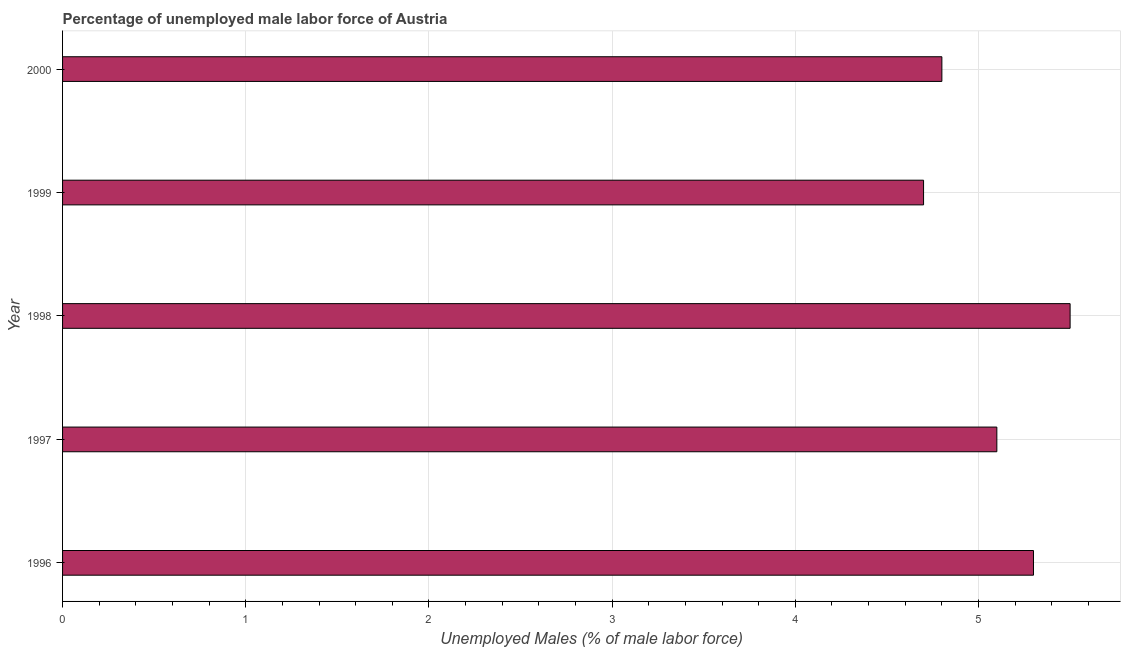Does the graph contain grids?
Your answer should be compact. Yes. What is the title of the graph?
Provide a short and direct response. Percentage of unemployed male labor force of Austria. What is the label or title of the X-axis?
Offer a terse response. Unemployed Males (% of male labor force). What is the total unemployed male labour force in 1997?
Your answer should be very brief. 5.1. Across all years, what is the maximum total unemployed male labour force?
Your answer should be compact. 5.5. Across all years, what is the minimum total unemployed male labour force?
Your answer should be very brief. 4.7. In which year was the total unemployed male labour force maximum?
Offer a very short reply. 1998. In which year was the total unemployed male labour force minimum?
Ensure brevity in your answer.  1999. What is the sum of the total unemployed male labour force?
Give a very brief answer. 25.4. What is the difference between the total unemployed male labour force in 1998 and 1999?
Offer a very short reply. 0.8. What is the average total unemployed male labour force per year?
Your answer should be very brief. 5.08. What is the median total unemployed male labour force?
Provide a succinct answer. 5.1. In how many years, is the total unemployed male labour force greater than 1 %?
Give a very brief answer. 5. What is the ratio of the total unemployed male labour force in 1996 to that in 1999?
Offer a terse response. 1.13. Is the total unemployed male labour force in 1997 less than that in 1998?
Provide a succinct answer. Yes. What is the difference between the highest and the second highest total unemployed male labour force?
Offer a very short reply. 0.2. Is the sum of the total unemployed male labour force in 1999 and 2000 greater than the maximum total unemployed male labour force across all years?
Make the answer very short. Yes. What is the difference between the highest and the lowest total unemployed male labour force?
Your answer should be very brief. 0.8. Are all the bars in the graph horizontal?
Provide a short and direct response. Yes. What is the Unemployed Males (% of male labor force) in 1996?
Offer a terse response. 5.3. What is the Unemployed Males (% of male labor force) in 1997?
Offer a terse response. 5.1. What is the Unemployed Males (% of male labor force) of 1998?
Make the answer very short. 5.5. What is the Unemployed Males (% of male labor force) in 1999?
Offer a terse response. 4.7. What is the Unemployed Males (% of male labor force) in 2000?
Offer a very short reply. 4.8. What is the difference between the Unemployed Males (% of male labor force) in 1996 and 1998?
Offer a very short reply. -0.2. What is the difference between the Unemployed Males (% of male labor force) in 1997 and 1998?
Provide a short and direct response. -0.4. What is the difference between the Unemployed Males (% of male labor force) in 1997 and 1999?
Give a very brief answer. 0.4. What is the difference between the Unemployed Males (% of male labor force) in 1998 and 1999?
Provide a succinct answer. 0.8. What is the difference between the Unemployed Males (% of male labor force) in 1998 and 2000?
Offer a terse response. 0.7. What is the difference between the Unemployed Males (% of male labor force) in 1999 and 2000?
Keep it short and to the point. -0.1. What is the ratio of the Unemployed Males (% of male labor force) in 1996 to that in 1997?
Keep it short and to the point. 1.04. What is the ratio of the Unemployed Males (% of male labor force) in 1996 to that in 1999?
Your answer should be very brief. 1.13. What is the ratio of the Unemployed Males (% of male labor force) in 1996 to that in 2000?
Provide a short and direct response. 1.1. What is the ratio of the Unemployed Males (% of male labor force) in 1997 to that in 1998?
Give a very brief answer. 0.93. What is the ratio of the Unemployed Males (% of male labor force) in 1997 to that in 1999?
Your answer should be very brief. 1.08. What is the ratio of the Unemployed Males (% of male labor force) in 1997 to that in 2000?
Make the answer very short. 1.06. What is the ratio of the Unemployed Males (% of male labor force) in 1998 to that in 1999?
Offer a very short reply. 1.17. What is the ratio of the Unemployed Males (% of male labor force) in 1998 to that in 2000?
Provide a short and direct response. 1.15. What is the ratio of the Unemployed Males (% of male labor force) in 1999 to that in 2000?
Give a very brief answer. 0.98. 